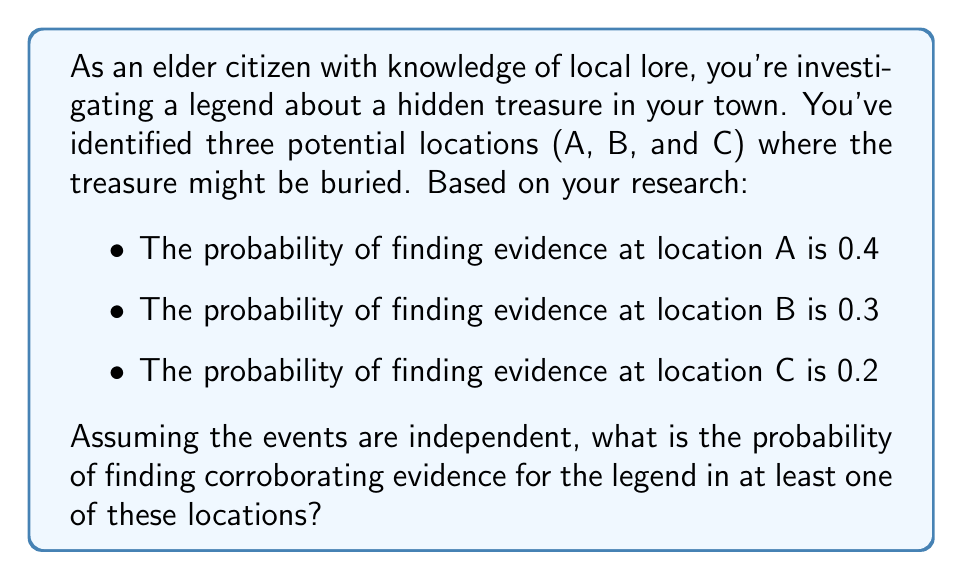Solve this math problem. To solve this problem, we'll use the complement rule of probability. Instead of calculating the probability of finding evidence in at least one location, we'll calculate the probability of not finding evidence in any location and then subtract that from 1.

Let's break it down step-by-step:

1) First, we need to calculate the probability of not finding evidence at each location:
   - P(not A) = 1 - 0.4 = 0.6
   - P(not B) = 1 - 0.3 = 0.7
   - P(not C) = 1 - 0.2 = 0.8

2) Since the events are independent, the probability of not finding evidence in any location is the product of the individual probabilities of not finding evidence:

   $$P(\text{no evidence}) = P(\text{not A}) \times P(\text{not B}) \times P(\text{not C})$$
   $$P(\text{no evidence}) = 0.6 \times 0.7 \times 0.8 = 0.336$$

3) Now, we can use the complement rule. The probability of finding evidence in at least one location is:

   $$P(\text{evidence in at least one}) = 1 - P(\text{no evidence})$$
   $$P(\text{evidence in at least one}) = 1 - 0.336 = 0.664$$

Therefore, the probability of finding corroborating evidence for the legend in at least one of these locations is 0.664 or 66.4%.
Answer: 0.664 or 66.4% 